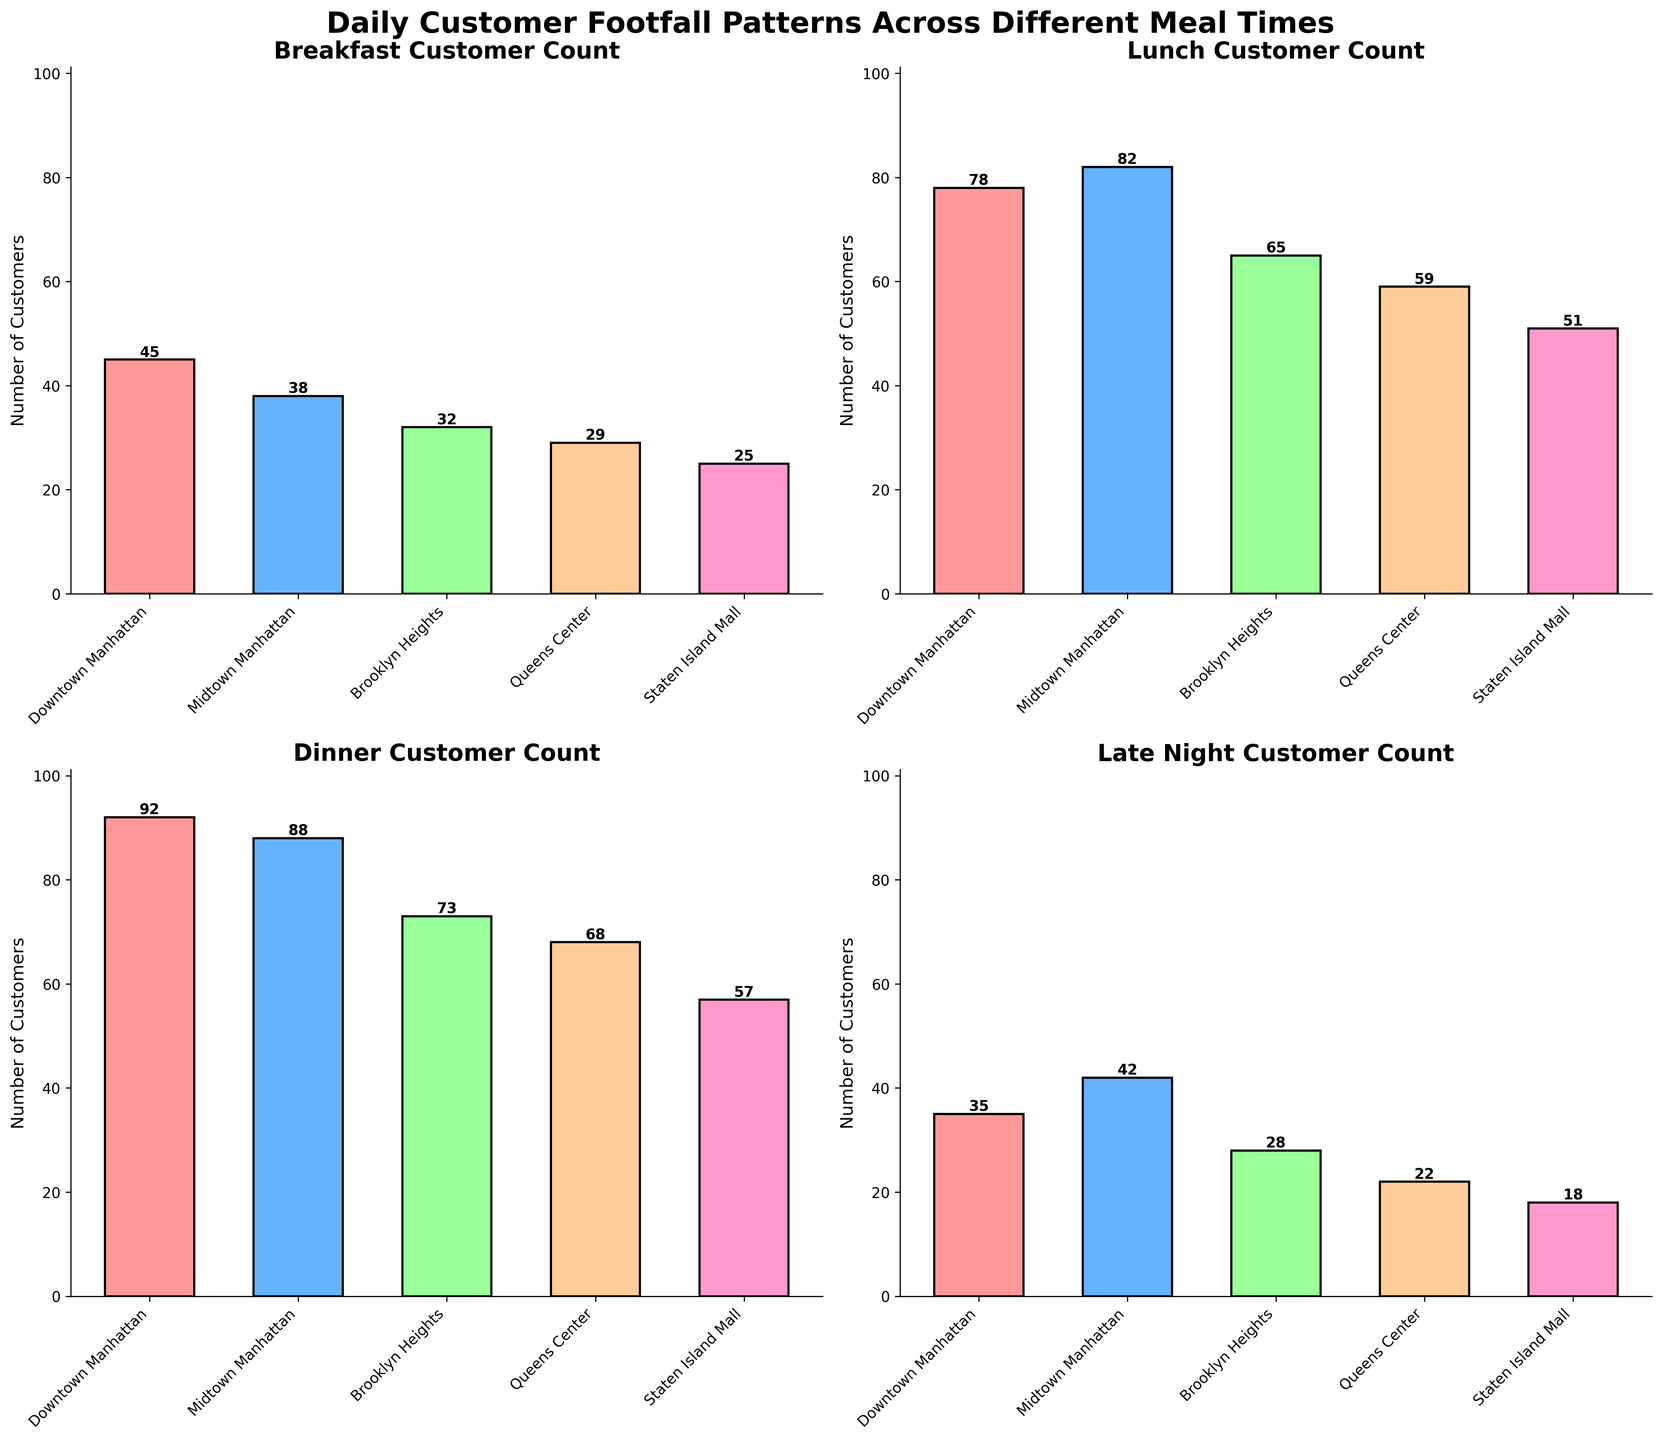What's the title of the figure? The title of the figure is centered at the top and is written in bold.
Answer: Daily Customer Footfall Patterns Across Different Meal Times How many subplots are there in the figure? The figure consists of multiple bars divided into different sections, each representing a subplot. Each subplot shows customer footfall for a different meal time. There are 4 subplots.
Answer: 4 Which restaurant location had the highest customer count for Breakfast? Look at the bar representing the footfall at different locations in the subplot titled "Breakfast Customer Count." The tallest bar corresponds to Downtown Manhattan.
Answer: Downtown Manhattan What is the difference in customer count between Downtown Manhattan and Queens Center during Lunch? In the Lunch subplot, identify the heights of the bars for Downtown Manhattan and Queens Center. Downtown Manhattan has 78 customers, and Queens Center has 59. The difference is calculated as 78 - 59.
Answer: 19 What is the trend in customer footfall from Breakfast to Dinner at Brooklyn Heights? Examine the heights of bars for Brooklyn Heights across the subplots for Breakfast, Lunch, and Dinner. The customer count increases from 32 in Breakfast, to 65 in Lunch, and then 73 in Dinner.
Answer: Increasing What is the average customer count for Staten Island Mall? Calculate the average of the customer counts at Staten Island Mall across the four subplots. Add the counts (25 for Breakfast, 51 for Lunch, 57 for Dinner, and 18 for Late Night) and divide by 4: (25 + 51 + 57 + 18) / 4.
Answer: 38.75 Which meal time has the lowest customer count for Midtown Manhattan? Look at the heights of the bars for Midtown Manhattan in all four subplots. The lowest bar height, indicating the fewest customers, is in Breakfast with 38 customers.
Answer: Breakfast Does Downtown Manhattan have more customers for Dinner or Late Night? Compare the heights of the bars for Downtown Manhattan in the Dinner and Late Night subplots. Dinner has 92 customers whereas Late Night has 35 customers. Therefore, Dinner has more customers.
Answer: Dinner Which restaurant location has the least variation in customer count across all meal times? Identify the restaurant location whose bars have the least vertical variation in height across the four subplots. The heights for different locations are most consistent for Staten Island Mall (25, 51, 57, 18). Calculating the range as the highest count minus the lowest (57 - 18).
Answer: Staten Island Mall 